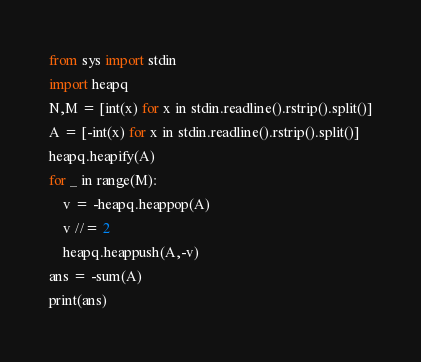<code> <loc_0><loc_0><loc_500><loc_500><_Python_>from sys import stdin
import heapq
N,M = [int(x) for x in stdin.readline().rstrip().split()]
A = [-int(x) for x in stdin.readline().rstrip().split()]
heapq.heapify(A)
for _ in range(M):
    v = -heapq.heappop(A)
    v //= 2
    heapq.heappush(A,-v)
ans = -sum(A)
print(ans)</code> 